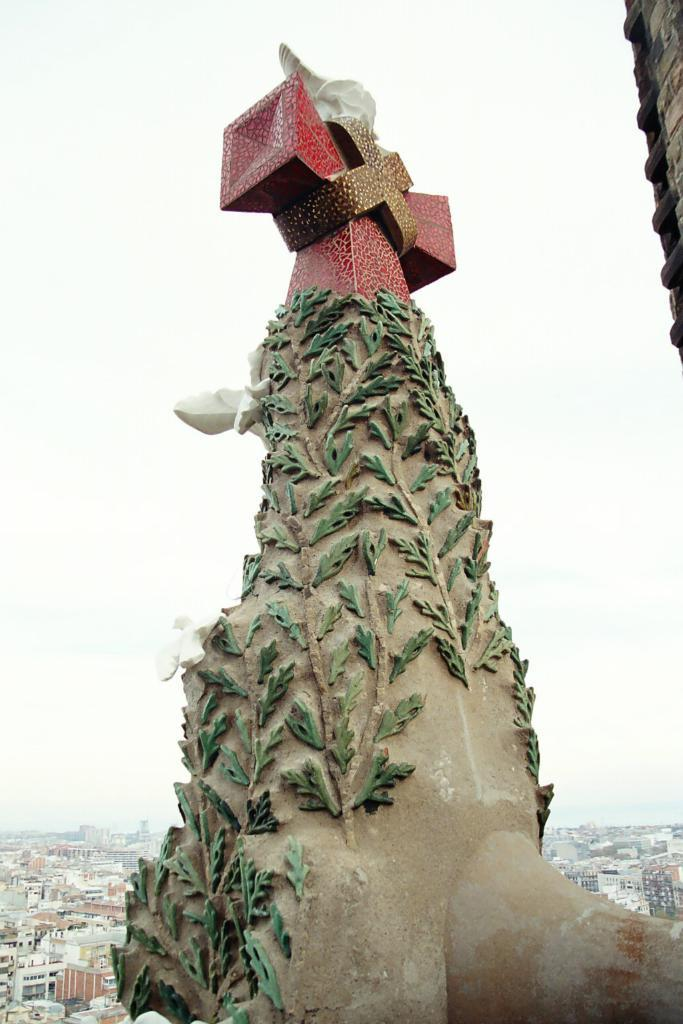What is the main subject of the image? There is a sculpture in the image. What can be seen in the background of the image? There are buildings and the sky visible in the background of the image. What type of butter is being used to create the sculpture in the image? There is no butter present in the image; it features a sculpture made of a different material. How many angles can be seen in the sculpture in the image? The question about angles is not relevant to the image, as it does not mention any angles or geometric shapes. 